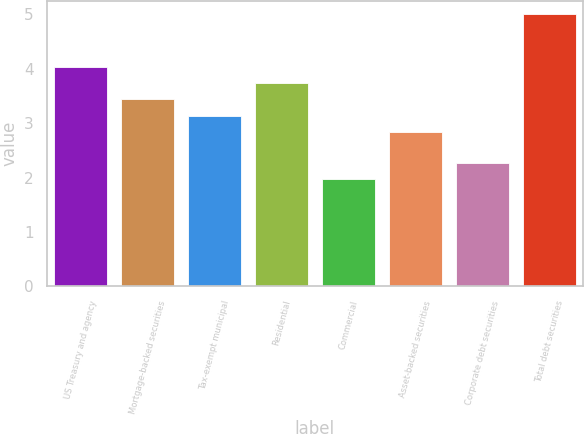<chart> <loc_0><loc_0><loc_500><loc_500><bar_chart><fcel>US Treasury and agency<fcel>Mortgage-backed securities<fcel>Tax-exempt municipal<fcel>Residential<fcel>Commercial<fcel>Asset-backed securities<fcel>Corporate debt securities<fcel>Total debt securities<nl><fcel>4.04<fcel>3.44<fcel>3.14<fcel>3.74<fcel>1.97<fcel>2.84<fcel>2.27<fcel>5<nl></chart> 